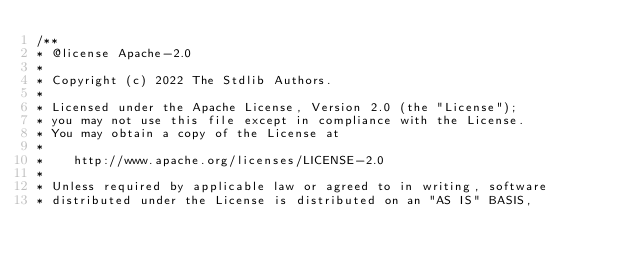Convert code to text. <code><loc_0><loc_0><loc_500><loc_500><_JavaScript_>/**
* @license Apache-2.0
*
* Copyright (c) 2022 The Stdlib Authors.
*
* Licensed under the Apache License, Version 2.0 (the "License");
* you may not use this file except in compliance with the License.
* You may obtain a copy of the License at
*
*    http://www.apache.org/licenses/LICENSE-2.0
*
* Unless required by applicable law or agreed to in writing, software
* distributed under the License is distributed on an "AS IS" BASIS,</code> 